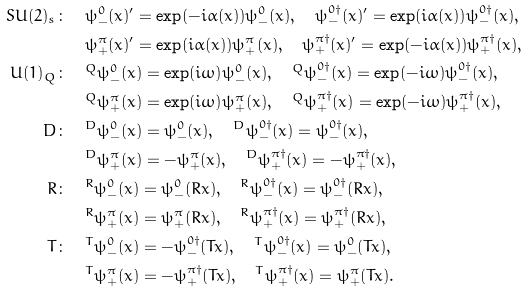<formula> <loc_0><loc_0><loc_500><loc_500>S U ( 2 ) _ { s } \colon & \quad \psi ^ { 0 } _ { - } ( x ) ^ { \prime } = \exp ( - i \alpha ( x ) ) \psi ^ { 0 } _ { - } ( x ) , \quad \psi ^ { 0 \dagger } _ { - } ( x ) ^ { \prime } = \exp ( i \alpha ( x ) ) \psi ^ { 0 \dagger } _ { - } ( x ) , \\ & \quad \psi ^ { \pi } _ { + } ( x ) ^ { \prime } = \exp ( i \alpha ( x ) ) \psi ^ { \pi } _ { + } ( x ) , \quad \psi ^ { \pi \dagger } _ { + } ( x ) ^ { \prime } = \exp ( - i \alpha ( x ) ) \psi ^ { \pi \dagger } _ { + } ( x ) , \\ U ( 1 ) _ { Q } \colon & \quad ^ { Q } \psi ^ { 0 } _ { - } ( x ) = \exp ( i \omega ) \psi ^ { 0 } _ { - } ( x ) , \quad ^ { Q } \psi ^ { 0 \dagger } _ { - } ( x ) = \exp ( - i \omega ) \psi ^ { 0 \dagger } _ { - } ( x ) , \\ & \quad ^ { Q } \psi ^ { \pi } _ { + } ( x ) = \exp ( i \omega ) \psi ^ { \pi } _ { + } ( x ) , \quad ^ { Q } \psi ^ { \pi \dagger } _ { + } ( x ) = \exp ( - i \omega ) \psi ^ { \pi \dagger } _ { + } ( x ) , \\ D \colon & \quad ^ { D } \psi ^ { 0 } _ { - } ( x ) = \psi ^ { 0 } _ { - } ( x ) , \quad ^ { D } \psi ^ { 0 \dagger } _ { - } ( x ) = \psi ^ { 0 \dagger } _ { - } ( x ) , \\ & \quad ^ { D } \psi ^ { \pi } _ { + } ( x ) = - \psi ^ { \pi } _ { + } ( x ) , \quad ^ { D } \psi ^ { \pi \dagger } _ { + } ( x ) = - \psi ^ { \pi \dagger } _ { + } ( x ) , \\ R \colon & \quad ^ { R } \psi ^ { 0 } _ { - } ( x ) = \psi ^ { 0 } _ { - } ( R x ) , \quad ^ { R } \psi ^ { 0 \dagger } _ { - } ( x ) = \psi ^ { 0 \dagger } _ { - } ( R x ) , \\ & \quad ^ { R } \psi ^ { \pi } _ { + } ( x ) = \psi ^ { \pi } _ { + } ( R x ) , \quad ^ { R } \psi ^ { \pi \dagger } _ { + } ( x ) = \psi ^ { \pi \dagger } _ { + } ( R x ) , \\ T \colon & \quad ^ { T } \psi ^ { 0 } _ { - } ( x ) = - \psi ^ { 0 \dagger } _ { - } ( T x ) , \quad ^ { T } \psi ^ { 0 \dagger } _ { - } ( x ) = \psi ^ { 0 } _ { - } ( T x ) , \\ & \quad ^ { T } \psi ^ { \pi } _ { + } ( x ) = - \psi ^ { \pi \dagger } _ { + } ( T x ) , \quad ^ { T } \psi ^ { \pi \dagger } _ { + } ( x ) = \psi ^ { \pi } _ { + } ( T x ) .</formula> 